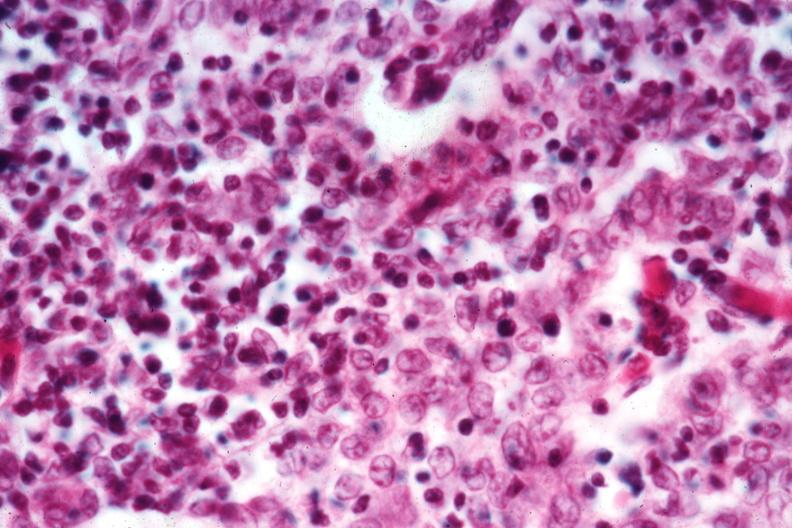does sickle cell disease show cellular detail well shown?
Answer the question using a single word or phrase. No 